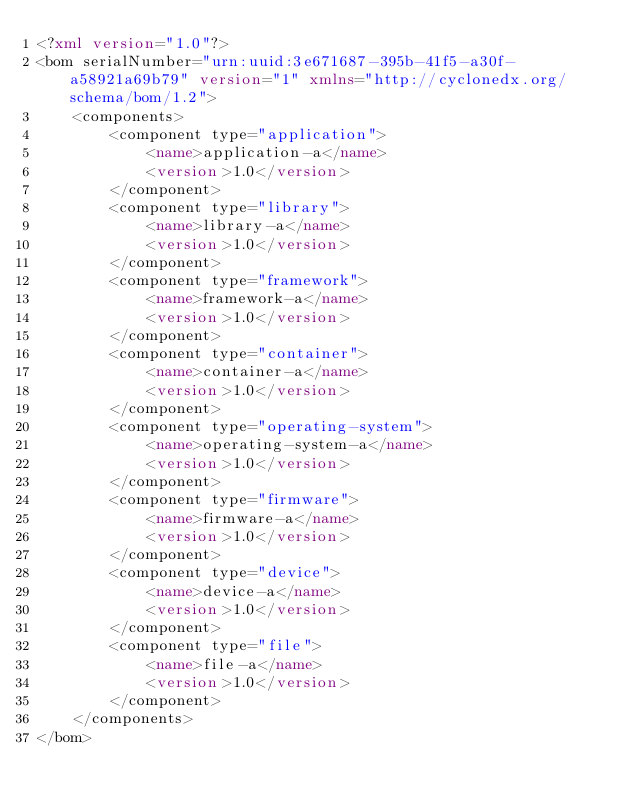Convert code to text. <code><loc_0><loc_0><loc_500><loc_500><_XML_><?xml version="1.0"?>
<bom serialNumber="urn:uuid:3e671687-395b-41f5-a30f-a58921a69b79" version="1" xmlns="http://cyclonedx.org/schema/bom/1.2">
    <components>
        <component type="application">
            <name>application-a</name>
            <version>1.0</version>
        </component>
        <component type="library">
            <name>library-a</name>
            <version>1.0</version>
        </component>
        <component type="framework">
            <name>framework-a</name>
            <version>1.0</version>
        </component>
        <component type="container">
            <name>container-a</name>
            <version>1.0</version>
        </component>
        <component type="operating-system">
            <name>operating-system-a</name>
            <version>1.0</version>
        </component>
        <component type="firmware">
            <name>firmware-a</name>
            <version>1.0</version>
        </component>
        <component type="device">
            <name>device-a</name>
            <version>1.0</version>
        </component>
        <component type="file">
            <name>file-a</name>
            <version>1.0</version>
        </component>
    </components>
</bom>
</code> 